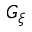Convert formula to latex. <formula><loc_0><loc_0><loc_500><loc_500>G _ { \xi }</formula> 